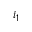Convert formula to latex. <formula><loc_0><loc_0><loc_500><loc_500>i _ { 1 }</formula> 